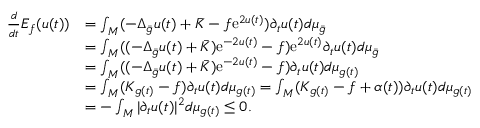<formula> <loc_0><loc_0><loc_500><loc_500>\begin{array} { r l } { \frac { d } { d t } E _ { f } ( u ( t ) ) } & { = \int _ { M } ( - \Delta _ { \bar { g } } u ( t ) + \bar { K } - f e ^ { 2 u ( t ) } ) \partial _ { t } u ( t ) d \mu _ { \bar { g } } } \\ & { = \int _ { M } ( ( - \Delta _ { \bar { g } } u ( t ) + \bar { K } ) e ^ { - 2 u ( t ) } - f ) e ^ { 2 u ( t ) } \partial _ { t } u ( t ) d \mu _ { \bar { g } } } \\ & { = \int _ { M } ( ( - \Delta _ { \bar { g } } u ( t ) + \bar { K } ) e ^ { - 2 u ( t ) } - f ) \partial _ { t } u ( t ) d \mu _ { g ( t ) } } \\ & { = \int _ { M } ( K _ { g ( t ) } - f ) \partial _ { t } u ( t ) d \mu _ { g ( t ) } = \int _ { M } ( K _ { g ( t ) } - f + \alpha ( t ) ) \partial _ { t } u ( t ) d \mu _ { g ( t ) } } \\ & { = - \int _ { M } | \partial _ { t } u ( t ) | ^ { 2 } d \mu _ { g ( t ) } \leq 0 . } \end{array}</formula> 